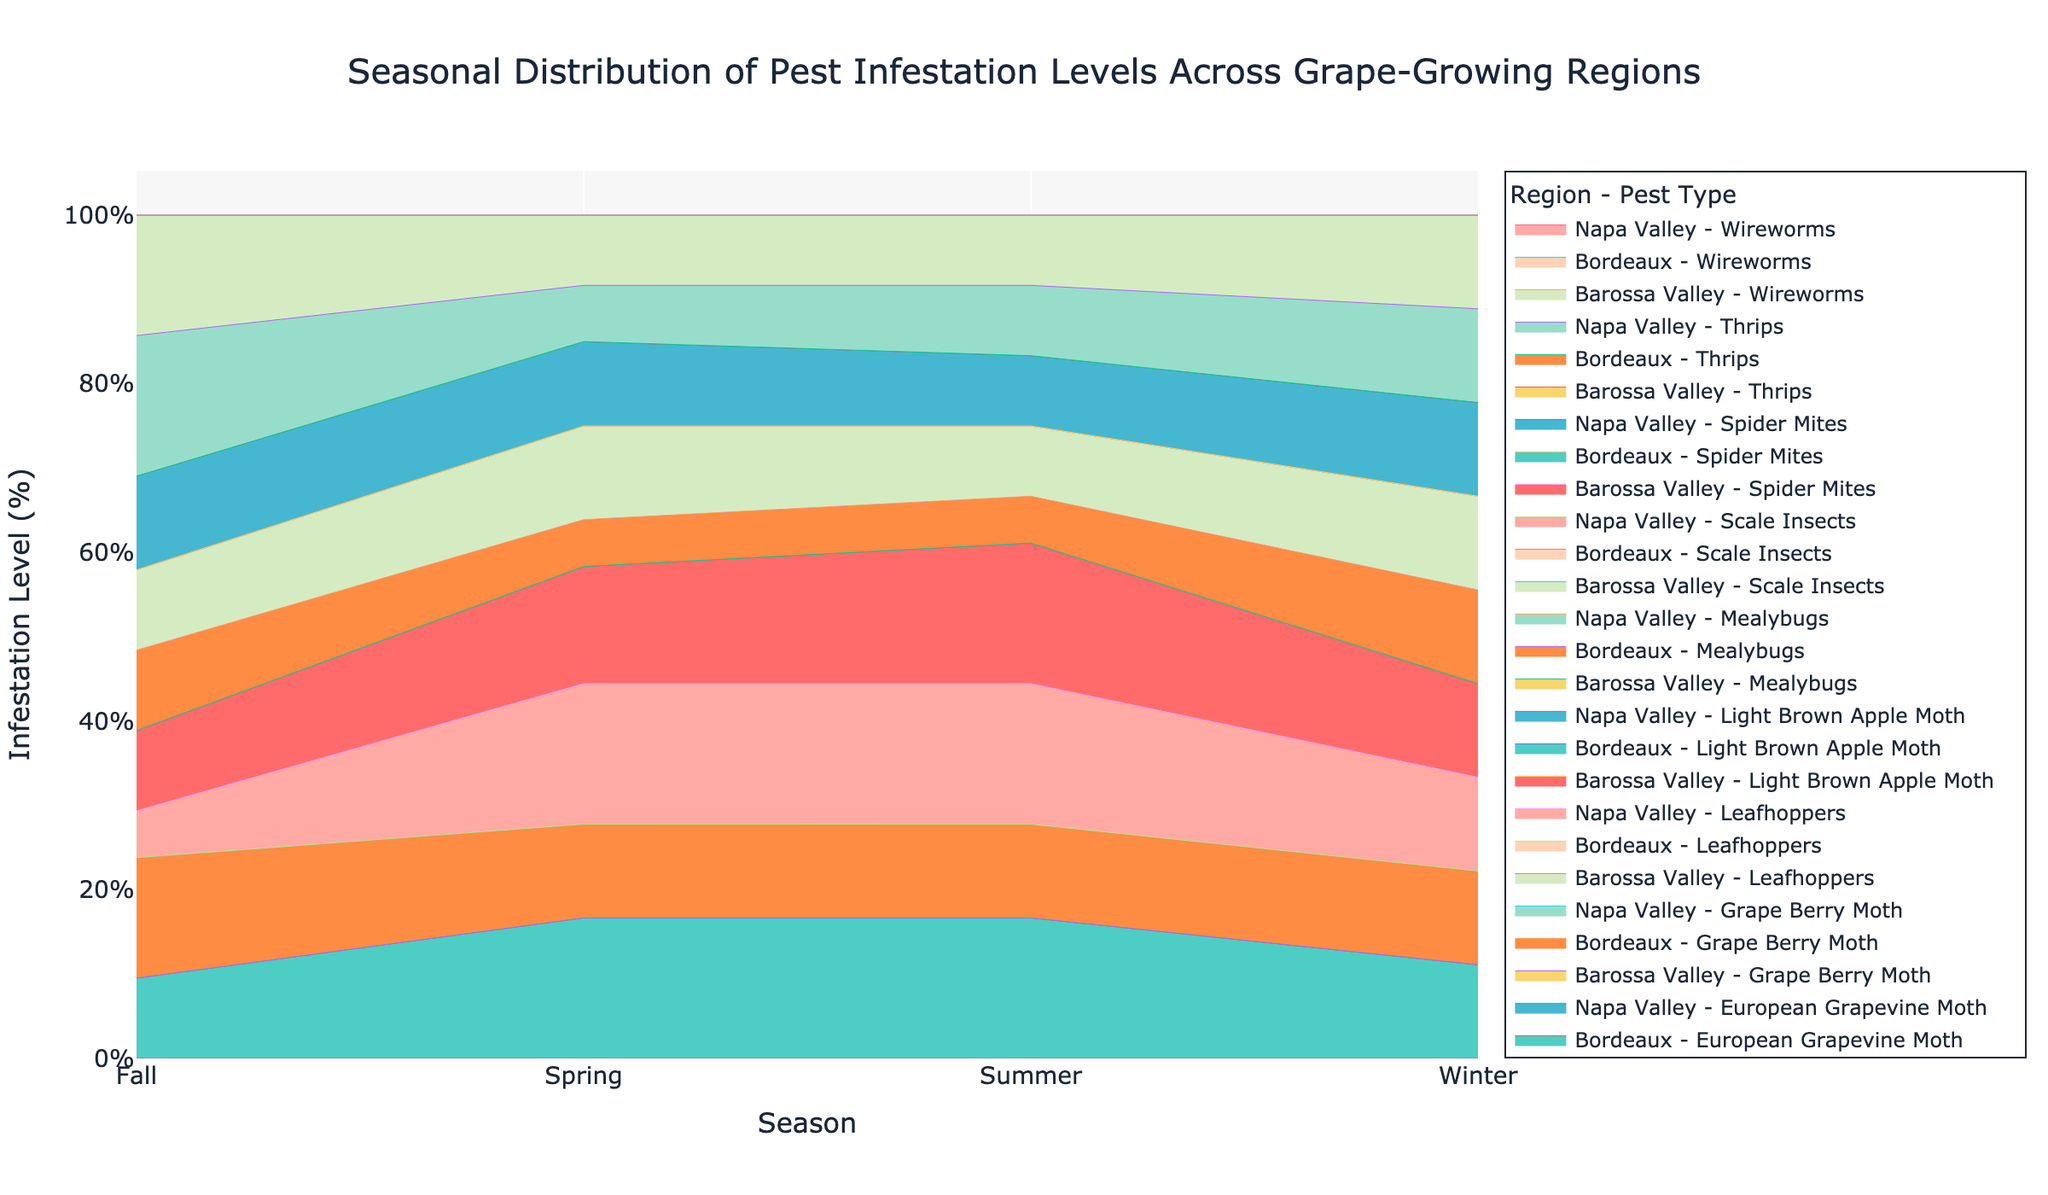What is the title of the chart? The title of the chart is usually displayed prominently at the top of the figure in a larger font.
Answer: Seasonal Distribution of Pest Infestation Levels Across Grape-Growing Regions Which region has the highest infestation level of Leafhoppers in Spring? Look at the colored areas representing Leafhoppers in Spring for each region. Compare their sizes to determine which one is the largest.
Answer: Napa Valley How does the infestation level of European Grapevine Moth in Bordeaux change from Spring to Winter? Trace the area representing European Grapevine Moth in Bordeaux across the seasons from Spring to Winter and observe the changes in height.
Answer: It decreases What is the overall trend of Spider Mites infestation in Napa Valley throughout the seasons? Follow the area representing Spider Mites in Napa Valley through Spring, Summer, Fall, and Winter. Note whether the area increases, decreases, or remains constant.
Answer: It fluctuates Compare the infestation levels of Thrips in Napa Valley and Bordeaux in Fall. Which has a higher infestation level? Look at the segments representing Thrips in both regions for Fall and compare their sizes.
Answer: Napa Valley Which pest type has the lowest infestation levels overall in Barossa Valley during Summer? Identify the areas representing different pest types in Barossa Valley for Summer and find the smallest one.
Answer: Wireworms In which season does Barossa Valley experience the highest infestation of Light Brown Apple Moth? Observe the section indicating Light Brown Apple Moth in Barossa Valley and find which season it is at its peak height.
Answer: Spring What percentage difference is there between infestation levels of Grape Berry Moth in Bordeaux between Spring and Summer? Calculate the difference in infestation levels of Grape Berry Moth in Bordeaux between Spring and Summer, then convert it to a percentage.
Answer: 10% Is the infestation level of Leafhoppers higher in Napa Valley during Spring or Summer? Compare the segmented areas representing Leafhoppers in Napa Valley during Spring and Summer and see which one is larger.
Answer: Spring How do the infestation levels of Scale Insects in Barossa Valley compare between Fall and Winter? Look at the segments representing Scale Insects in Barossa Valley for Fall and Winter and compare their sizes.
Answer: Same 